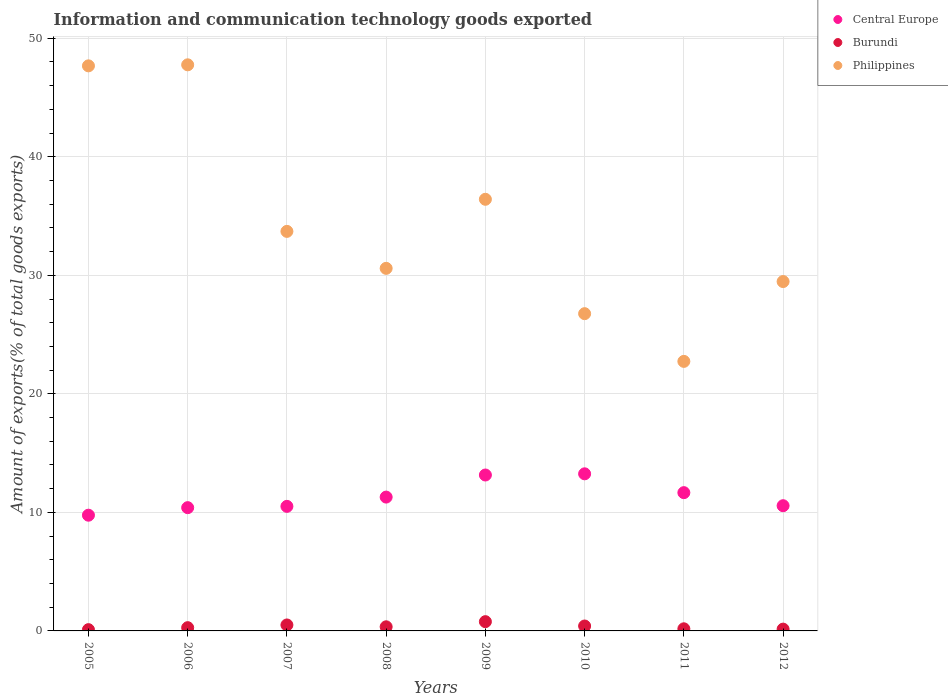How many different coloured dotlines are there?
Provide a succinct answer. 3. Is the number of dotlines equal to the number of legend labels?
Make the answer very short. Yes. What is the amount of goods exported in Burundi in 2008?
Your response must be concise. 0.35. Across all years, what is the maximum amount of goods exported in Burundi?
Your response must be concise. 0.78. Across all years, what is the minimum amount of goods exported in Central Europe?
Provide a short and direct response. 9.76. In which year was the amount of goods exported in Philippines maximum?
Ensure brevity in your answer.  2006. What is the total amount of goods exported in Burundi in the graph?
Your answer should be compact. 2.76. What is the difference between the amount of goods exported in Central Europe in 2006 and that in 2007?
Give a very brief answer. -0.11. What is the difference between the amount of goods exported in Burundi in 2005 and the amount of goods exported in Philippines in 2009?
Ensure brevity in your answer.  -36.31. What is the average amount of goods exported in Burundi per year?
Your response must be concise. 0.34. In the year 2011, what is the difference between the amount of goods exported in Philippines and amount of goods exported in Burundi?
Offer a very short reply. 22.56. What is the ratio of the amount of goods exported in Philippines in 2010 to that in 2012?
Keep it short and to the point. 0.91. Is the difference between the amount of goods exported in Philippines in 2005 and 2012 greater than the difference between the amount of goods exported in Burundi in 2005 and 2012?
Your answer should be very brief. Yes. What is the difference between the highest and the second highest amount of goods exported in Central Europe?
Provide a short and direct response. 0.1. What is the difference between the highest and the lowest amount of goods exported in Philippines?
Provide a succinct answer. 25.02. Is it the case that in every year, the sum of the amount of goods exported in Central Europe and amount of goods exported in Philippines  is greater than the amount of goods exported in Burundi?
Give a very brief answer. Yes. Does the amount of goods exported in Philippines monotonically increase over the years?
Keep it short and to the point. No. Does the graph contain grids?
Offer a terse response. Yes. Where does the legend appear in the graph?
Your answer should be very brief. Top right. How are the legend labels stacked?
Provide a short and direct response. Vertical. What is the title of the graph?
Give a very brief answer. Information and communication technology goods exported. Does "Madagascar" appear as one of the legend labels in the graph?
Ensure brevity in your answer.  No. What is the label or title of the X-axis?
Your answer should be compact. Years. What is the label or title of the Y-axis?
Ensure brevity in your answer.  Amount of exports(% of total goods exports). What is the Amount of exports(% of total goods exports) of Central Europe in 2005?
Ensure brevity in your answer.  9.76. What is the Amount of exports(% of total goods exports) in Burundi in 2005?
Your answer should be very brief. 0.11. What is the Amount of exports(% of total goods exports) of Philippines in 2005?
Provide a short and direct response. 47.67. What is the Amount of exports(% of total goods exports) in Central Europe in 2006?
Your response must be concise. 10.4. What is the Amount of exports(% of total goods exports) in Burundi in 2006?
Make the answer very short. 0.27. What is the Amount of exports(% of total goods exports) in Philippines in 2006?
Keep it short and to the point. 47.76. What is the Amount of exports(% of total goods exports) of Central Europe in 2007?
Ensure brevity in your answer.  10.51. What is the Amount of exports(% of total goods exports) of Burundi in 2007?
Your answer should be compact. 0.5. What is the Amount of exports(% of total goods exports) of Philippines in 2007?
Offer a very short reply. 33.71. What is the Amount of exports(% of total goods exports) of Central Europe in 2008?
Give a very brief answer. 11.29. What is the Amount of exports(% of total goods exports) of Burundi in 2008?
Offer a very short reply. 0.35. What is the Amount of exports(% of total goods exports) of Philippines in 2008?
Your response must be concise. 30.59. What is the Amount of exports(% of total goods exports) in Central Europe in 2009?
Your response must be concise. 13.15. What is the Amount of exports(% of total goods exports) in Burundi in 2009?
Provide a short and direct response. 0.78. What is the Amount of exports(% of total goods exports) in Philippines in 2009?
Make the answer very short. 36.42. What is the Amount of exports(% of total goods exports) of Central Europe in 2010?
Ensure brevity in your answer.  13.25. What is the Amount of exports(% of total goods exports) of Burundi in 2010?
Make the answer very short. 0.41. What is the Amount of exports(% of total goods exports) in Philippines in 2010?
Provide a succinct answer. 26.77. What is the Amount of exports(% of total goods exports) in Central Europe in 2011?
Give a very brief answer. 11.67. What is the Amount of exports(% of total goods exports) in Burundi in 2011?
Your answer should be very brief. 0.18. What is the Amount of exports(% of total goods exports) of Philippines in 2011?
Give a very brief answer. 22.74. What is the Amount of exports(% of total goods exports) of Central Europe in 2012?
Provide a succinct answer. 10.56. What is the Amount of exports(% of total goods exports) in Burundi in 2012?
Ensure brevity in your answer.  0.15. What is the Amount of exports(% of total goods exports) of Philippines in 2012?
Provide a short and direct response. 29.47. Across all years, what is the maximum Amount of exports(% of total goods exports) of Central Europe?
Offer a terse response. 13.25. Across all years, what is the maximum Amount of exports(% of total goods exports) in Burundi?
Offer a very short reply. 0.78. Across all years, what is the maximum Amount of exports(% of total goods exports) of Philippines?
Ensure brevity in your answer.  47.76. Across all years, what is the minimum Amount of exports(% of total goods exports) of Central Europe?
Offer a terse response. 9.76. Across all years, what is the minimum Amount of exports(% of total goods exports) of Burundi?
Ensure brevity in your answer.  0.11. Across all years, what is the minimum Amount of exports(% of total goods exports) in Philippines?
Offer a terse response. 22.74. What is the total Amount of exports(% of total goods exports) of Central Europe in the graph?
Your response must be concise. 90.6. What is the total Amount of exports(% of total goods exports) in Burundi in the graph?
Give a very brief answer. 2.76. What is the total Amount of exports(% of total goods exports) of Philippines in the graph?
Provide a short and direct response. 275.13. What is the difference between the Amount of exports(% of total goods exports) in Central Europe in 2005 and that in 2006?
Provide a succinct answer. -0.64. What is the difference between the Amount of exports(% of total goods exports) of Burundi in 2005 and that in 2006?
Ensure brevity in your answer.  -0.17. What is the difference between the Amount of exports(% of total goods exports) of Philippines in 2005 and that in 2006?
Offer a terse response. -0.09. What is the difference between the Amount of exports(% of total goods exports) in Central Europe in 2005 and that in 2007?
Keep it short and to the point. -0.74. What is the difference between the Amount of exports(% of total goods exports) in Burundi in 2005 and that in 2007?
Your answer should be compact. -0.4. What is the difference between the Amount of exports(% of total goods exports) of Philippines in 2005 and that in 2007?
Offer a very short reply. 13.97. What is the difference between the Amount of exports(% of total goods exports) in Central Europe in 2005 and that in 2008?
Provide a succinct answer. -1.53. What is the difference between the Amount of exports(% of total goods exports) of Burundi in 2005 and that in 2008?
Your answer should be very brief. -0.24. What is the difference between the Amount of exports(% of total goods exports) in Philippines in 2005 and that in 2008?
Provide a short and direct response. 17.08. What is the difference between the Amount of exports(% of total goods exports) in Central Europe in 2005 and that in 2009?
Your answer should be very brief. -3.39. What is the difference between the Amount of exports(% of total goods exports) of Burundi in 2005 and that in 2009?
Your response must be concise. -0.67. What is the difference between the Amount of exports(% of total goods exports) in Philippines in 2005 and that in 2009?
Provide a succinct answer. 11.26. What is the difference between the Amount of exports(% of total goods exports) of Central Europe in 2005 and that in 2010?
Offer a very short reply. -3.49. What is the difference between the Amount of exports(% of total goods exports) in Burundi in 2005 and that in 2010?
Offer a very short reply. -0.31. What is the difference between the Amount of exports(% of total goods exports) in Philippines in 2005 and that in 2010?
Keep it short and to the point. 20.91. What is the difference between the Amount of exports(% of total goods exports) in Central Europe in 2005 and that in 2011?
Provide a short and direct response. -1.9. What is the difference between the Amount of exports(% of total goods exports) of Burundi in 2005 and that in 2011?
Offer a terse response. -0.07. What is the difference between the Amount of exports(% of total goods exports) in Philippines in 2005 and that in 2011?
Your answer should be very brief. 24.93. What is the difference between the Amount of exports(% of total goods exports) of Central Europe in 2005 and that in 2012?
Give a very brief answer. -0.8. What is the difference between the Amount of exports(% of total goods exports) in Burundi in 2005 and that in 2012?
Ensure brevity in your answer.  -0.04. What is the difference between the Amount of exports(% of total goods exports) of Philippines in 2005 and that in 2012?
Offer a terse response. 18.2. What is the difference between the Amount of exports(% of total goods exports) in Central Europe in 2006 and that in 2007?
Make the answer very short. -0.11. What is the difference between the Amount of exports(% of total goods exports) in Burundi in 2006 and that in 2007?
Your answer should be compact. -0.23. What is the difference between the Amount of exports(% of total goods exports) in Philippines in 2006 and that in 2007?
Keep it short and to the point. 14.05. What is the difference between the Amount of exports(% of total goods exports) of Central Europe in 2006 and that in 2008?
Your answer should be compact. -0.89. What is the difference between the Amount of exports(% of total goods exports) in Burundi in 2006 and that in 2008?
Provide a succinct answer. -0.07. What is the difference between the Amount of exports(% of total goods exports) in Philippines in 2006 and that in 2008?
Keep it short and to the point. 17.17. What is the difference between the Amount of exports(% of total goods exports) in Central Europe in 2006 and that in 2009?
Make the answer very short. -2.75. What is the difference between the Amount of exports(% of total goods exports) of Burundi in 2006 and that in 2009?
Give a very brief answer. -0.51. What is the difference between the Amount of exports(% of total goods exports) of Philippines in 2006 and that in 2009?
Keep it short and to the point. 11.35. What is the difference between the Amount of exports(% of total goods exports) of Central Europe in 2006 and that in 2010?
Provide a succinct answer. -2.85. What is the difference between the Amount of exports(% of total goods exports) of Burundi in 2006 and that in 2010?
Make the answer very short. -0.14. What is the difference between the Amount of exports(% of total goods exports) in Philippines in 2006 and that in 2010?
Your answer should be very brief. 20.99. What is the difference between the Amount of exports(% of total goods exports) of Central Europe in 2006 and that in 2011?
Your answer should be compact. -1.27. What is the difference between the Amount of exports(% of total goods exports) of Burundi in 2006 and that in 2011?
Give a very brief answer. 0.09. What is the difference between the Amount of exports(% of total goods exports) of Philippines in 2006 and that in 2011?
Offer a terse response. 25.02. What is the difference between the Amount of exports(% of total goods exports) of Central Europe in 2006 and that in 2012?
Give a very brief answer. -0.16. What is the difference between the Amount of exports(% of total goods exports) of Burundi in 2006 and that in 2012?
Offer a terse response. 0.12. What is the difference between the Amount of exports(% of total goods exports) of Philippines in 2006 and that in 2012?
Provide a short and direct response. 18.29. What is the difference between the Amount of exports(% of total goods exports) in Central Europe in 2007 and that in 2008?
Your response must be concise. -0.78. What is the difference between the Amount of exports(% of total goods exports) in Burundi in 2007 and that in 2008?
Offer a very short reply. 0.16. What is the difference between the Amount of exports(% of total goods exports) of Philippines in 2007 and that in 2008?
Ensure brevity in your answer.  3.12. What is the difference between the Amount of exports(% of total goods exports) of Central Europe in 2007 and that in 2009?
Keep it short and to the point. -2.65. What is the difference between the Amount of exports(% of total goods exports) of Burundi in 2007 and that in 2009?
Your response must be concise. -0.28. What is the difference between the Amount of exports(% of total goods exports) in Philippines in 2007 and that in 2009?
Offer a terse response. -2.71. What is the difference between the Amount of exports(% of total goods exports) in Central Europe in 2007 and that in 2010?
Offer a terse response. -2.75. What is the difference between the Amount of exports(% of total goods exports) in Burundi in 2007 and that in 2010?
Ensure brevity in your answer.  0.09. What is the difference between the Amount of exports(% of total goods exports) of Philippines in 2007 and that in 2010?
Your response must be concise. 6.94. What is the difference between the Amount of exports(% of total goods exports) in Central Europe in 2007 and that in 2011?
Provide a short and direct response. -1.16. What is the difference between the Amount of exports(% of total goods exports) in Burundi in 2007 and that in 2011?
Your answer should be very brief. 0.32. What is the difference between the Amount of exports(% of total goods exports) in Philippines in 2007 and that in 2011?
Ensure brevity in your answer.  10.97. What is the difference between the Amount of exports(% of total goods exports) in Central Europe in 2007 and that in 2012?
Offer a very short reply. -0.06. What is the difference between the Amount of exports(% of total goods exports) in Burundi in 2007 and that in 2012?
Your answer should be very brief. 0.35. What is the difference between the Amount of exports(% of total goods exports) in Philippines in 2007 and that in 2012?
Provide a short and direct response. 4.23. What is the difference between the Amount of exports(% of total goods exports) in Central Europe in 2008 and that in 2009?
Ensure brevity in your answer.  -1.86. What is the difference between the Amount of exports(% of total goods exports) in Burundi in 2008 and that in 2009?
Keep it short and to the point. -0.43. What is the difference between the Amount of exports(% of total goods exports) of Philippines in 2008 and that in 2009?
Your answer should be compact. -5.83. What is the difference between the Amount of exports(% of total goods exports) of Central Europe in 2008 and that in 2010?
Make the answer very short. -1.96. What is the difference between the Amount of exports(% of total goods exports) of Burundi in 2008 and that in 2010?
Keep it short and to the point. -0.07. What is the difference between the Amount of exports(% of total goods exports) of Philippines in 2008 and that in 2010?
Your answer should be very brief. 3.82. What is the difference between the Amount of exports(% of total goods exports) in Central Europe in 2008 and that in 2011?
Ensure brevity in your answer.  -0.37. What is the difference between the Amount of exports(% of total goods exports) of Burundi in 2008 and that in 2011?
Your answer should be very brief. 0.17. What is the difference between the Amount of exports(% of total goods exports) in Philippines in 2008 and that in 2011?
Your answer should be compact. 7.85. What is the difference between the Amount of exports(% of total goods exports) of Central Europe in 2008 and that in 2012?
Offer a terse response. 0.73. What is the difference between the Amount of exports(% of total goods exports) of Burundi in 2008 and that in 2012?
Your answer should be very brief. 0.2. What is the difference between the Amount of exports(% of total goods exports) in Philippines in 2008 and that in 2012?
Offer a terse response. 1.11. What is the difference between the Amount of exports(% of total goods exports) in Central Europe in 2009 and that in 2010?
Give a very brief answer. -0.1. What is the difference between the Amount of exports(% of total goods exports) in Burundi in 2009 and that in 2010?
Offer a very short reply. 0.37. What is the difference between the Amount of exports(% of total goods exports) of Philippines in 2009 and that in 2010?
Make the answer very short. 9.65. What is the difference between the Amount of exports(% of total goods exports) of Central Europe in 2009 and that in 2011?
Give a very brief answer. 1.49. What is the difference between the Amount of exports(% of total goods exports) in Burundi in 2009 and that in 2011?
Provide a short and direct response. 0.6. What is the difference between the Amount of exports(% of total goods exports) of Philippines in 2009 and that in 2011?
Provide a short and direct response. 13.68. What is the difference between the Amount of exports(% of total goods exports) of Central Europe in 2009 and that in 2012?
Your response must be concise. 2.59. What is the difference between the Amount of exports(% of total goods exports) of Burundi in 2009 and that in 2012?
Provide a short and direct response. 0.63. What is the difference between the Amount of exports(% of total goods exports) of Philippines in 2009 and that in 2012?
Offer a terse response. 6.94. What is the difference between the Amount of exports(% of total goods exports) in Central Europe in 2010 and that in 2011?
Your response must be concise. 1.59. What is the difference between the Amount of exports(% of total goods exports) of Burundi in 2010 and that in 2011?
Offer a very short reply. 0.23. What is the difference between the Amount of exports(% of total goods exports) of Philippines in 2010 and that in 2011?
Make the answer very short. 4.03. What is the difference between the Amount of exports(% of total goods exports) in Central Europe in 2010 and that in 2012?
Your answer should be very brief. 2.69. What is the difference between the Amount of exports(% of total goods exports) of Burundi in 2010 and that in 2012?
Keep it short and to the point. 0.26. What is the difference between the Amount of exports(% of total goods exports) in Philippines in 2010 and that in 2012?
Offer a terse response. -2.71. What is the difference between the Amount of exports(% of total goods exports) in Central Europe in 2011 and that in 2012?
Your answer should be very brief. 1.1. What is the difference between the Amount of exports(% of total goods exports) of Burundi in 2011 and that in 2012?
Offer a terse response. 0.03. What is the difference between the Amount of exports(% of total goods exports) in Philippines in 2011 and that in 2012?
Offer a very short reply. -6.73. What is the difference between the Amount of exports(% of total goods exports) in Central Europe in 2005 and the Amount of exports(% of total goods exports) in Burundi in 2006?
Your answer should be compact. 9.49. What is the difference between the Amount of exports(% of total goods exports) of Central Europe in 2005 and the Amount of exports(% of total goods exports) of Philippines in 2006?
Ensure brevity in your answer.  -38. What is the difference between the Amount of exports(% of total goods exports) in Burundi in 2005 and the Amount of exports(% of total goods exports) in Philippines in 2006?
Keep it short and to the point. -47.65. What is the difference between the Amount of exports(% of total goods exports) of Central Europe in 2005 and the Amount of exports(% of total goods exports) of Burundi in 2007?
Keep it short and to the point. 9.26. What is the difference between the Amount of exports(% of total goods exports) in Central Europe in 2005 and the Amount of exports(% of total goods exports) in Philippines in 2007?
Offer a terse response. -23.95. What is the difference between the Amount of exports(% of total goods exports) in Burundi in 2005 and the Amount of exports(% of total goods exports) in Philippines in 2007?
Provide a short and direct response. -33.6. What is the difference between the Amount of exports(% of total goods exports) in Central Europe in 2005 and the Amount of exports(% of total goods exports) in Burundi in 2008?
Give a very brief answer. 9.42. What is the difference between the Amount of exports(% of total goods exports) in Central Europe in 2005 and the Amount of exports(% of total goods exports) in Philippines in 2008?
Provide a short and direct response. -20.83. What is the difference between the Amount of exports(% of total goods exports) of Burundi in 2005 and the Amount of exports(% of total goods exports) of Philippines in 2008?
Give a very brief answer. -30.48. What is the difference between the Amount of exports(% of total goods exports) of Central Europe in 2005 and the Amount of exports(% of total goods exports) of Burundi in 2009?
Ensure brevity in your answer.  8.98. What is the difference between the Amount of exports(% of total goods exports) in Central Europe in 2005 and the Amount of exports(% of total goods exports) in Philippines in 2009?
Make the answer very short. -26.65. What is the difference between the Amount of exports(% of total goods exports) in Burundi in 2005 and the Amount of exports(% of total goods exports) in Philippines in 2009?
Make the answer very short. -36.31. What is the difference between the Amount of exports(% of total goods exports) in Central Europe in 2005 and the Amount of exports(% of total goods exports) in Burundi in 2010?
Offer a terse response. 9.35. What is the difference between the Amount of exports(% of total goods exports) in Central Europe in 2005 and the Amount of exports(% of total goods exports) in Philippines in 2010?
Offer a terse response. -17. What is the difference between the Amount of exports(% of total goods exports) of Burundi in 2005 and the Amount of exports(% of total goods exports) of Philippines in 2010?
Ensure brevity in your answer.  -26.66. What is the difference between the Amount of exports(% of total goods exports) of Central Europe in 2005 and the Amount of exports(% of total goods exports) of Burundi in 2011?
Your answer should be compact. 9.58. What is the difference between the Amount of exports(% of total goods exports) of Central Europe in 2005 and the Amount of exports(% of total goods exports) of Philippines in 2011?
Provide a short and direct response. -12.98. What is the difference between the Amount of exports(% of total goods exports) of Burundi in 2005 and the Amount of exports(% of total goods exports) of Philippines in 2011?
Your answer should be very brief. -22.63. What is the difference between the Amount of exports(% of total goods exports) in Central Europe in 2005 and the Amount of exports(% of total goods exports) in Burundi in 2012?
Offer a terse response. 9.61. What is the difference between the Amount of exports(% of total goods exports) of Central Europe in 2005 and the Amount of exports(% of total goods exports) of Philippines in 2012?
Ensure brevity in your answer.  -19.71. What is the difference between the Amount of exports(% of total goods exports) of Burundi in 2005 and the Amount of exports(% of total goods exports) of Philippines in 2012?
Keep it short and to the point. -29.37. What is the difference between the Amount of exports(% of total goods exports) in Central Europe in 2006 and the Amount of exports(% of total goods exports) in Burundi in 2007?
Make the answer very short. 9.9. What is the difference between the Amount of exports(% of total goods exports) in Central Europe in 2006 and the Amount of exports(% of total goods exports) in Philippines in 2007?
Offer a very short reply. -23.31. What is the difference between the Amount of exports(% of total goods exports) of Burundi in 2006 and the Amount of exports(% of total goods exports) of Philippines in 2007?
Provide a succinct answer. -33.43. What is the difference between the Amount of exports(% of total goods exports) in Central Europe in 2006 and the Amount of exports(% of total goods exports) in Burundi in 2008?
Provide a short and direct response. 10.05. What is the difference between the Amount of exports(% of total goods exports) of Central Europe in 2006 and the Amount of exports(% of total goods exports) of Philippines in 2008?
Your answer should be very brief. -20.19. What is the difference between the Amount of exports(% of total goods exports) of Burundi in 2006 and the Amount of exports(% of total goods exports) of Philippines in 2008?
Provide a succinct answer. -30.32. What is the difference between the Amount of exports(% of total goods exports) of Central Europe in 2006 and the Amount of exports(% of total goods exports) of Burundi in 2009?
Your answer should be compact. 9.62. What is the difference between the Amount of exports(% of total goods exports) in Central Europe in 2006 and the Amount of exports(% of total goods exports) in Philippines in 2009?
Ensure brevity in your answer.  -26.02. What is the difference between the Amount of exports(% of total goods exports) of Burundi in 2006 and the Amount of exports(% of total goods exports) of Philippines in 2009?
Provide a succinct answer. -36.14. What is the difference between the Amount of exports(% of total goods exports) in Central Europe in 2006 and the Amount of exports(% of total goods exports) in Burundi in 2010?
Make the answer very short. 9.99. What is the difference between the Amount of exports(% of total goods exports) in Central Europe in 2006 and the Amount of exports(% of total goods exports) in Philippines in 2010?
Make the answer very short. -16.37. What is the difference between the Amount of exports(% of total goods exports) of Burundi in 2006 and the Amount of exports(% of total goods exports) of Philippines in 2010?
Make the answer very short. -26.49. What is the difference between the Amount of exports(% of total goods exports) in Central Europe in 2006 and the Amount of exports(% of total goods exports) in Burundi in 2011?
Offer a terse response. 10.22. What is the difference between the Amount of exports(% of total goods exports) in Central Europe in 2006 and the Amount of exports(% of total goods exports) in Philippines in 2011?
Make the answer very short. -12.34. What is the difference between the Amount of exports(% of total goods exports) of Burundi in 2006 and the Amount of exports(% of total goods exports) of Philippines in 2011?
Keep it short and to the point. -22.47. What is the difference between the Amount of exports(% of total goods exports) of Central Europe in 2006 and the Amount of exports(% of total goods exports) of Burundi in 2012?
Ensure brevity in your answer.  10.25. What is the difference between the Amount of exports(% of total goods exports) in Central Europe in 2006 and the Amount of exports(% of total goods exports) in Philippines in 2012?
Provide a short and direct response. -19.08. What is the difference between the Amount of exports(% of total goods exports) in Burundi in 2006 and the Amount of exports(% of total goods exports) in Philippines in 2012?
Ensure brevity in your answer.  -29.2. What is the difference between the Amount of exports(% of total goods exports) in Central Europe in 2007 and the Amount of exports(% of total goods exports) in Burundi in 2008?
Your answer should be compact. 10.16. What is the difference between the Amount of exports(% of total goods exports) of Central Europe in 2007 and the Amount of exports(% of total goods exports) of Philippines in 2008?
Provide a succinct answer. -20.08. What is the difference between the Amount of exports(% of total goods exports) in Burundi in 2007 and the Amount of exports(% of total goods exports) in Philippines in 2008?
Your answer should be very brief. -30.09. What is the difference between the Amount of exports(% of total goods exports) of Central Europe in 2007 and the Amount of exports(% of total goods exports) of Burundi in 2009?
Ensure brevity in your answer.  9.73. What is the difference between the Amount of exports(% of total goods exports) of Central Europe in 2007 and the Amount of exports(% of total goods exports) of Philippines in 2009?
Your answer should be compact. -25.91. What is the difference between the Amount of exports(% of total goods exports) in Burundi in 2007 and the Amount of exports(% of total goods exports) in Philippines in 2009?
Offer a very short reply. -35.91. What is the difference between the Amount of exports(% of total goods exports) of Central Europe in 2007 and the Amount of exports(% of total goods exports) of Burundi in 2010?
Provide a short and direct response. 10.09. What is the difference between the Amount of exports(% of total goods exports) in Central Europe in 2007 and the Amount of exports(% of total goods exports) in Philippines in 2010?
Keep it short and to the point. -16.26. What is the difference between the Amount of exports(% of total goods exports) in Burundi in 2007 and the Amount of exports(% of total goods exports) in Philippines in 2010?
Provide a short and direct response. -26.26. What is the difference between the Amount of exports(% of total goods exports) in Central Europe in 2007 and the Amount of exports(% of total goods exports) in Burundi in 2011?
Provide a succinct answer. 10.33. What is the difference between the Amount of exports(% of total goods exports) in Central Europe in 2007 and the Amount of exports(% of total goods exports) in Philippines in 2011?
Your response must be concise. -12.23. What is the difference between the Amount of exports(% of total goods exports) of Burundi in 2007 and the Amount of exports(% of total goods exports) of Philippines in 2011?
Offer a terse response. -22.24. What is the difference between the Amount of exports(% of total goods exports) in Central Europe in 2007 and the Amount of exports(% of total goods exports) in Burundi in 2012?
Provide a short and direct response. 10.36. What is the difference between the Amount of exports(% of total goods exports) in Central Europe in 2007 and the Amount of exports(% of total goods exports) in Philippines in 2012?
Offer a terse response. -18.97. What is the difference between the Amount of exports(% of total goods exports) of Burundi in 2007 and the Amount of exports(% of total goods exports) of Philippines in 2012?
Offer a very short reply. -28.97. What is the difference between the Amount of exports(% of total goods exports) in Central Europe in 2008 and the Amount of exports(% of total goods exports) in Burundi in 2009?
Give a very brief answer. 10.51. What is the difference between the Amount of exports(% of total goods exports) of Central Europe in 2008 and the Amount of exports(% of total goods exports) of Philippines in 2009?
Your answer should be very brief. -25.12. What is the difference between the Amount of exports(% of total goods exports) in Burundi in 2008 and the Amount of exports(% of total goods exports) in Philippines in 2009?
Your response must be concise. -36.07. What is the difference between the Amount of exports(% of total goods exports) of Central Europe in 2008 and the Amount of exports(% of total goods exports) of Burundi in 2010?
Provide a short and direct response. 10.88. What is the difference between the Amount of exports(% of total goods exports) in Central Europe in 2008 and the Amount of exports(% of total goods exports) in Philippines in 2010?
Make the answer very short. -15.47. What is the difference between the Amount of exports(% of total goods exports) of Burundi in 2008 and the Amount of exports(% of total goods exports) of Philippines in 2010?
Provide a succinct answer. -26.42. What is the difference between the Amount of exports(% of total goods exports) of Central Europe in 2008 and the Amount of exports(% of total goods exports) of Burundi in 2011?
Make the answer very short. 11.11. What is the difference between the Amount of exports(% of total goods exports) in Central Europe in 2008 and the Amount of exports(% of total goods exports) in Philippines in 2011?
Keep it short and to the point. -11.45. What is the difference between the Amount of exports(% of total goods exports) in Burundi in 2008 and the Amount of exports(% of total goods exports) in Philippines in 2011?
Keep it short and to the point. -22.39. What is the difference between the Amount of exports(% of total goods exports) of Central Europe in 2008 and the Amount of exports(% of total goods exports) of Burundi in 2012?
Ensure brevity in your answer.  11.14. What is the difference between the Amount of exports(% of total goods exports) of Central Europe in 2008 and the Amount of exports(% of total goods exports) of Philippines in 2012?
Your answer should be very brief. -18.18. What is the difference between the Amount of exports(% of total goods exports) in Burundi in 2008 and the Amount of exports(% of total goods exports) in Philippines in 2012?
Provide a succinct answer. -29.13. What is the difference between the Amount of exports(% of total goods exports) in Central Europe in 2009 and the Amount of exports(% of total goods exports) in Burundi in 2010?
Offer a very short reply. 12.74. What is the difference between the Amount of exports(% of total goods exports) in Central Europe in 2009 and the Amount of exports(% of total goods exports) in Philippines in 2010?
Ensure brevity in your answer.  -13.61. What is the difference between the Amount of exports(% of total goods exports) of Burundi in 2009 and the Amount of exports(% of total goods exports) of Philippines in 2010?
Your answer should be compact. -25.98. What is the difference between the Amount of exports(% of total goods exports) of Central Europe in 2009 and the Amount of exports(% of total goods exports) of Burundi in 2011?
Ensure brevity in your answer.  12.98. What is the difference between the Amount of exports(% of total goods exports) in Central Europe in 2009 and the Amount of exports(% of total goods exports) in Philippines in 2011?
Offer a very short reply. -9.59. What is the difference between the Amount of exports(% of total goods exports) of Burundi in 2009 and the Amount of exports(% of total goods exports) of Philippines in 2011?
Your answer should be compact. -21.96. What is the difference between the Amount of exports(% of total goods exports) of Central Europe in 2009 and the Amount of exports(% of total goods exports) of Burundi in 2012?
Ensure brevity in your answer.  13. What is the difference between the Amount of exports(% of total goods exports) in Central Europe in 2009 and the Amount of exports(% of total goods exports) in Philippines in 2012?
Provide a succinct answer. -16.32. What is the difference between the Amount of exports(% of total goods exports) of Burundi in 2009 and the Amount of exports(% of total goods exports) of Philippines in 2012?
Provide a short and direct response. -28.69. What is the difference between the Amount of exports(% of total goods exports) of Central Europe in 2010 and the Amount of exports(% of total goods exports) of Burundi in 2011?
Offer a very short reply. 13.07. What is the difference between the Amount of exports(% of total goods exports) in Central Europe in 2010 and the Amount of exports(% of total goods exports) in Philippines in 2011?
Provide a short and direct response. -9.49. What is the difference between the Amount of exports(% of total goods exports) in Burundi in 2010 and the Amount of exports(% of total goods exports) in Philippines in 2011?
Give a very brief answer. -22.33. What is the difference between the Amount of exports(% of total goods exports) of Central Europe in 2010 and the Amount of exports(% of total goods exports) of Burundi in 2012?
Offer a very short reply. 13.1. What is the difference between the Amount of exports(% of total goods exports) in Central Europe in 2010 and the Amount of exports(% of total goods exports) in Philippines in 2012?
Ensure brevity in your answer.  -16.22. What is the difference between the Amount of exports(% of total goods exports) in Burundi in 2010 and the Amount of exports(% of total goods exports) in Philippines in 2012?
Provide a short and direct response. -29.06. What is the difference between the Amount of exports(% of total goods exports) of Central Europe in 2011 and the Amount of exports(% of total goods exports) of Burundi in 2012?
Provide a short and direct response. 11.51. What is the difference between the Amount of exports(% of total goods exports) of Central Europe in 2011 and the Amount of exports(% of total goods exports) of Philippines in 2012?
Provide a succinct answer. -17.81. What is the difference between the Amount of exports(% of total goods exports) in Burundi in 2011 and the Amount of exports(% of total goods exports) in Philippines in 2012?
Provide a short and direct response. -29.3. What is the average Amount of exports(% of total goods exports) in Central Europe per year?
Your answer should be very brief. 11.32. What is the average Amount of exports(% of total goods exports) of Burundi per year?
Your answer should be very brief. 0.34. What is the average Amount of exports(% of total goods exports) of Philippines per year?
Ensure brevity in your answer.  34.39. In the year 2005, what is the difference between the Amount of exports(% of total goods exports) of Central Europe and Amount of exports(% of total goods exports) of Burundi?
Keep it short and to the point. 9.66. In the year 2005, what is the difference between the Amount of exports(% of total goods exports) of Central Europe and Amount of exports(% of total goods exports) of Philippines?
Your answer should be very brief. -37.91. In the year 2005, what is the difference between the Amount of exports(% of total goods exports) of Burundi and Amount of exports(% of total goods exports) of Philippines?
Give a very brief answer. -47.57. In the year 2006, what is the difference between the Amount of exports(% of total goods exports) of Central Europe and Amount of exports(% of total goods exports) of Burundi?
Your answer should be very brief. 10.13. In the year 2006, what is the difference between the Amount of exports(% of total goods exports) of Central Europe and Amount of exports(% of total goods exports) of Philippines?
Your response must be concise. -37.36. In the year 2006, what is the difference between the Amount of exports(% of total goods exports) of Burundi and Amount of exports(% of total goods exports) of Philippines?
Provide a short and direct response. -47.49. In the year 2007, what is the difference between the Amount of exports(% of total goods exports) of Central Europe and Amount of exports(% of total goods exports) of Burundi?
Offer a very short reply. 10. In the year 2007, what is the difference between the Amount of exports(% of total goods exports) in Central Europe and Amount of exports(% of total goods exports) in Philippines?
Your answer should be compact. -23.2. In the year 2007, what is the difference between the Amount of exports(% of total goods exports) in Burundi and Amount of exports(% of total goods exports) in Philippines?
Keep it short and to the point. -33.21. In the year 2008, what is the difference between the Amount of exports(% of total goods exports) of Central Europe and Amount of exports(% of total goods exports) of Burundi?
Offer a terse response. 10.94. In the year 2008, what is the difference between the Amount of exports(% of total goods exports) of Central Europe and Amount of exports(% of total goods exports) of Philippines?
Ensure brevity in your answer.  -19.3. In the year 2008, what is the difference between the Amount of exports(% of total goods exports) of Burundi and Amount of exports(% of total goods exports) of Philippines?
Your answer should be very brief. -30.24. In the year 2009, what is the difference between the Amount of exports(% of total goods exports) in Central Europe and Amount of exports(% of total goods exports) in Burundi?
Ensure brevity in your answer.  12.37. In the year 2009, what is the difference between the Amount of exports(% of total goods exports) in Central Europe and Amount of exports(% of total goods exports) in Philippines?
Keep it short and to the point. -23.26. In the year 2009, what is the difference between the Amount of exports(% of total goods exports) in Burundi and Amount of exports(% of total goods exports) in Philippines?
Keep it short and to the point. -35.63. In the year 2010, what is the difference between the Amount of exports(% of total goods exports) in Central Europe and Amount of exports(% of total goods exports) in Burundi?
Provide a succinct answer. 12.84. In the year 2010, what is the difference between the Amount of exports(% of total goods exports) in Central Europe and Amount of exports(% of total goods exports) in Philippines?
Keep it short and to the point. -13.51. In the year 2010, what is the difference between the Amount of exports(% of total goods exports) of Burundi and Amount of exports(% of total goods exports) of Philippines?
Provide a short and direct response. -26.35. In the year 2011, what is the difference between the Amount of exports(% of total goods exports) in Central Europe and Amount of exports(% of total goods exports) in Burundi?
Make the answer very short. 11.49. In the year 2011, what is the difference between the Amount of exports(% of total goods exports) in Central Europe and Amount of exports(% of total goods exports) in Philippines?
Your answer should be very brief. -11.07. In the year 2011, what is the difference between the Amount of exports(% of total goods exports) in Burundi and Amount of exports(% of total goods exports) in Philippines?
Your response must be concise. -22.56. In the year 2012, what is the difference between the Amount of exports(% of total goods exports) of Central Europe and Amount of exports(% of total goods exports) of Burundi?
Your answer should be very brief. 10.41. In the year 2012, what is the difference between the Amount of exports(% of total goods exports) in Central Europe and Amount of exports(% of total goods exports) in Philippines?
Your response must be concise. -18.91. In the year 2012, what is the difference between the Amount of exports(% of total goods exports) of Burundi and Amount of exports(% of total goods exports) of Philippines?
Ensure brevity in your answer.  -29.32. What is the ratio of the Amount of exports(% of total goods exports) of Central Europe in 2005 to that in 2006?
Offer a terse response. 0.94. What is the ratio of the Amount of exports(% of total goods exports) in Burundi in 2005 to that in 2006?
Your answer should be very brief. 0.39. What is the ratio of the Amount of exports(% of total goods exports) of Philippines in 2005 to that in 2006?
Your answer should be very brief. 1. What is the ratio of the Amount of exports(% of total goods exports) in Central Europe in 2005 to that in 2007?
Make the answer very short. 0.93. What is the ratio of the Amount of exports(% of total goods exports) in Burundi in 2005 to that in 2007?
Make the answer very short. 0.21. What is the ratio of the Amount of exports(% of total goods exports) in Philippines in 2005 to that in 2007?
Your response must be concise. 1.41. What is the ratio of the Amount of exports(% of total goods exports) in Central Europe in 2005 to that in 2008?
Your answer should be very brief. 0.86. What is the ratio of the Amount of exports(% of total goods exports) of Burundi in 2005 to that in 2008?
Make the answer very short. 0.31. What is the ratio of the Amount of exports(% of total goods exports) of Philippines in 2005 to that in 2008?
Offer a terse response. 1.56. What is the ratio of the Amount of exports(% of total goods exports) of Central Europe in 2005 to that in 2009?
Give a very brief answer. 0.74. What is the ratio of the Amount of exports(% of total goods exports) in Burundi in 2005 to that in 2009?
Your answer should be very brief. 0.14. What is the ratio of the Amount of exports(% of total goods exports) in Philippines in 2005 to that in 2009?
Your answer should be very brief. 1.31. What is the ratio of the Amount of exports(% of total goods exports) in Central Europe in 2005 to that in 2010?
Keep it short and to the point. 0.74. What is the ratio of the Amount of exports(% of total goods exports) of Burundi in 2005 to that in 2010?
Provide a short and direct response. 0.26. What is the ratio of the Amount of exports(% of total goods exports) in Philippines in 2005 to that in 2010?
Your answer should be compact. 1.78. What is the ratio of the Amount of exports(% of total goods exports) in Central Europe in 2005 to that in 2011?
Make the answer very short. 0.84. What is the ratio of the Amount of exports(% of total goods exports) of Burundi in 2005 to that in 2011?
Your answer should be very brief. 0.6. What is the ratio of the Amount of exports(% of total goods exports) in Philippines in 2005 to that in 2011?
Keep it short and to the point. 2.1. What is the ratio of the Amount of exports(% of total goods exports) of Central Europe in 2005 to that in 2012?
Your response must be concise. 0.92. What is the ratio of the Amount of exports(% of total goods exports) of Burundi in 2005 to that in 2012?
Give a very brief answer. 0.71. What is the ratio of the Amount of exports(% of total goods exports) of Philippines in 2005 to that in 2012?
Provide a succinct answer. 1.62. What is the ratio of the Amount of exports(% of total goods exports) in Central Europe in 2006 to that in 2007?
Your answer should be compact. 0.99. What is the ratio of the Amount of exports(% of total goods exports) in Burundi in 2006 to that in 2007?
Keep it short and to the point. 0.55. What is the ratio of the Amount of exports(% of total goods exports) in Philippines in 2006 to that in 2007?
Provide a short and direct response. 1.42. What is the ratio of the Amount of exports(% of total goods exports) in Central Europe in 2006 to that in 2008?
Make the answer very short. 0.92. What is the ratio of the Amount of exports(% of total goods exports) of Burundi in 2006 to that in 2008?
Offer a terse response. 0.79. What is the ratio of the Amount of exports(% of total goods exports) of Philippines in 2006 to that in 2008?
Give a very brief answer. 1.56. What is the ratio of the Amount of exports(% of total goods exports) of Central Europe in 2006 to that in 2009?
Your answer should be compact. 0.79. What is the ratio of the Amount of exports(% of total goods exports) of Burundi in 2006 to that in 2009?
Your answer should be very brief. 0.35. What is the ratio of the Amount of exports(% of total goods exports) in Philippines in 2006 to that in 2009?
Provide a succinct answer. 1.31. What is the ratio of the Amount of exports(% of total goods exports) of Central Europe in 2006 to that in 2010?
Offer a very short reply. 0.78. What is the ratio of the Amount of exports(% of total goods exports) of Burundi in 2006 to that in 2010?
Offer a terse response. 0.66. What is the ratio of the Amount of exports(% of total goods exports) of Philippines in 2006 to that in 2010?
Provide a short and direct response. 1.78. What is the ratio of the Amount of exports(% of total goods exports) of Central Europe in 2006 to that in 2011?
Offer a terse response. 0.89. What is the ratio of the Amount of exports(% of total goods exports) in Burundi in 2006 to that in 2011?
Offer a very short reply. 1.53. What is the ratio of the Amount of exports(% of total goods exports) of Philippines in 2006 to that in 2011?
Offer a very short reply. 2.1. What is the ratio of the Amount of exports(% of total goods exports) in Central Europe in 2006 to that in 2012?
Your answer should be compact. 0.98. What is the ratio of the Amount of exports(% of total goods exports) in Burundi in 2006 to that in 2012?
Make the answer very short. 1.81. What is the ratio of the Amount of exports(% of total goods exports) in Philippines in 2006 to that in 2012?
Provide a short and direct response. 1.62. What is the ratio of the Amount of exports(% of total goods exports) in Central Europe in 2007 to that in 2008?
Provide a succinct answer. 0.93. What is the ratio of the Amount of exports(% of total goods exports) in Burundi in 2007 to that in 2008?
Your answer should be very brief. 1.45. What is the ratio of the Amount of exports(% of total goods exports) in Philippines in 2007 to that in 2008?
Provide a short and direct response. 1.1. What is the ratio of the Amount of exports(% of total goods exports) in Central Europe in 2007 to that in 2009?
Provide a succinct answer. 0.8. What is the ratio of the Amount of exports(% of total goods exports) of Burundi in 2007 to that in 2009?
Provide a short and direct response. 0.64. What is the ratio of the Amount of exports(% of total goods exports) of Philippines in 2007 to that in 2009?
Provide a succinct answer. 0.93. What is the ratio of the Amount of exports(% of total goods exports) of Central Europe in 2007 to that in 2010?
Provide a short and direct response. 0.79. What is the ratio of the Amount of exports(% of total goods exports) of Burundi in 2007 to that in 2010?
Your answer should be compact. 1.21. What is the ratio of the Amount of exports(% of total goods exports) of Philippines in 2007 to that in 2010?
Ensure brevity in your answer.  1.26. What is the ratio of the Amount of exports(% of total goods exports) of Central Europe in 2007 to that in 2011?
Your answer should be compact. 0.9. What is the ratio of the Amount of exports(% of total goods exports) in Burundi in 2007 to that in 2011?
Offer a terse response. 2.81. What is the ratio of the Amount of exports(% of total goods exports) in Philippines in 2007 to that in 2011?
Offer a terse response. 1.48. What is the ratio of the Amount of exports(% of total goods exports) of Central Europe in 2007 to that in 2012?
Offer a terse response. 0.99. What is the ratio of the Amount of exports(% of total goods exports) of Burundi in 2007 to that in 2012?
Provide a succinct answer. 3.32. What is the ratio of the Amount of exports(% of total goods exports) of Philippines in 2007 to that in 2012?
Your response must be concise. 1.14. What is the ratio of the Amount of exports(% of total goods exports) of Central Europe in 2008 to that in 2009?
Offer a very short reply. 0.86. What is the ratio of the Amount of exports(% of total goods exports) in Burundi in 2008 to that in 2009?
Ensure brevity in your answer.  0.45. What is the ratio of the Amount of exports(% of total goods exports) in Philippines in 2008 to that in 2009?
Ensure brevity in your answer.  0.84. What is the ratio of the Amount of exports(% of total goods exports) in Central Europe in 2008 to that in 2010?
Provide a short and direct response. 0.85. What is the ratio of the Amount of exports(% of total goods exports) of Burundi in 2008 to that in 2010?
Your answer should be compact. 0.84. What is the ratio of the Amount of exports(% of total goods exports) in Philippines in 2008 to that in 2010?
Offer a very short reply. 1.14. What is the ratio of the Amount of exports(% of total goods exports) in Central Europe in 2008 to that in 2011?
Your answer should be compact. 0.97. What is the ratio of the Amount of exports(% of total goods exports) of Burundi in 2008 to that in 2011?
Make the answer very short. 1.94. What is the ratio of the Amount of exports(% of total goods exports) in Philippines in 2008 to that in 2011?
Offer a terse response. 1.35. What is the ratio of the Amount of exports(% of total goods exports) of Central Europe in 2008 to that in 2012?
Keep it short and to the point. 1.07. What is the ratio of the Amount of exports(% of total goods exports) of Burundi in 2008 to that in 2012?
Offer a terse response. 2.29. What is the ratio of the Amount of exports(% of total goods exports) of Philippines in 2008 to that in 2012?
Your answer should be very brief. 1.04. What is the ratio of the Amount of exports(% of total goods exports) of Central Europe in 2009 to that in 2010?
Keep it short and to the point. 0.99. What is the ratio of the Amount of exports(% of total goods exports) in Burundi in 2009 to that in 2010?
Provide a short and direct response. 1.89. What is the ratio of the Amount of exports(% of total goods exports) in Philippines in 2009 to that in 2010?
Offer a very short reply. 1.36. What is the ratio of the Amount of exports(% of total goods exports) in Central Europe in 2009 to that in 2011?
Your answer should be very brief. 1.13. What is the ratio of the Amount of exports(% of total goods exports) of Burundi in 2009 to that in 2011?
Keep it short and to the point. 4.36. What is the ratio of the Amount of exports(% of total goods exports) of Philippines in 2009 to that in 2011?
Your answer should be compact. 1.6. What is the ratio of the Amount of exports(% of total goods exports) of Central Europe in 2009 to that in 2012?
Provide a succinct answer. 1.25. What is the ratio of the Amount of exports(% of total goods exports) of Burundi in 2009 to that in 2012?
Keep it short and to the point. 5.15. What is the ratio of the Amount of exports(% of total goods exports) of Philippines in 2009 to that in 2012?
Your response must be concise. 1.24. What is the ratio of the Amount of exports(% of total goods exports) of Central Europe in 2010 to that in 2011?
Provide a short and direct response. 1.14. What is the ratio of the Amount of exports(% of total goods exports) of Burundi in 2010 to that in 2011?
Your answer should be very brief. 2.31. What is the ratio of the Amount of exports(% of total goods exports) of Philippines in 2010 to that in 2011?
Keep it short and to the point. 1.18. What is the ratio of the Amount of exports(% of total goods exports) of Central Europe in 2010 to that in 2012?
Make the answer very short. 1.25. What is the ratio of the Amount of exports(% of total goods exports) in Burundi in 2010 to that in 2012?
Offer a terse response. 2.73. What is the ratio of the Amount of exports(% of total goods exports) of Philippines in 2010 to that in 2012?
Provide a succinct answer. 0.91. What is the ratio of the Amount of exports(% of total goods exports) of Central Europe in 2011 to that in 2012?
Your response must be concise. 1.1. What is the ratio of the Amount of exports(% of total goods exports) in Burundi in 2011 to that in 2012?
Provide a succinct answer. 1.18. What is the ratio of the Amount of exports(% of total goods exports) in Philippines in 2011 to that in 2012?
Give a very brief answer. 0.77. What is the difference between the highest and the second highest Amount of exports(% of total goods exports) of Central Europe?
Provide a short and direct response. 0.1. What is the difference between the highest and the second highest Amount of exports(% of total goods exports) in Burundi?
Your answer should be compact. 0.28. What is the difference between the highest and the second highest Amount of exports(% of total goods exports) of Philippines?
Make the answer very short. 0.09. What is the difference between the highest and the lowest Amount of exports(% of total goods exports) in Central Europe?
Provide a succinct answer. 3.49. What is the difference between the highest and the lowest Amount of exports(% of total goods exports) in Burundi?
Your answer should be very brief. 0.67. What is the difference between the highest and the lowest Amount of exports(% of total goods exports) of Philippines?
Provide a short and direct response. 25.02. 